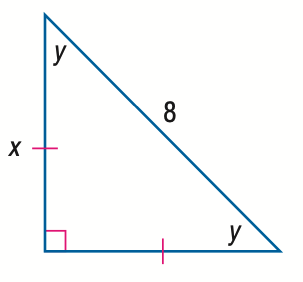Question: Find x.
Choices:
A. 4
B. 4 \sqrt { 2 }
C. 4 \sqrt { 3 }
D. 8
Answer with the letter. Answer: B Question: Find y.
Choices:
A. 30
B. 45
C. 60
D. 90
Answer with the letter. Answer: B 